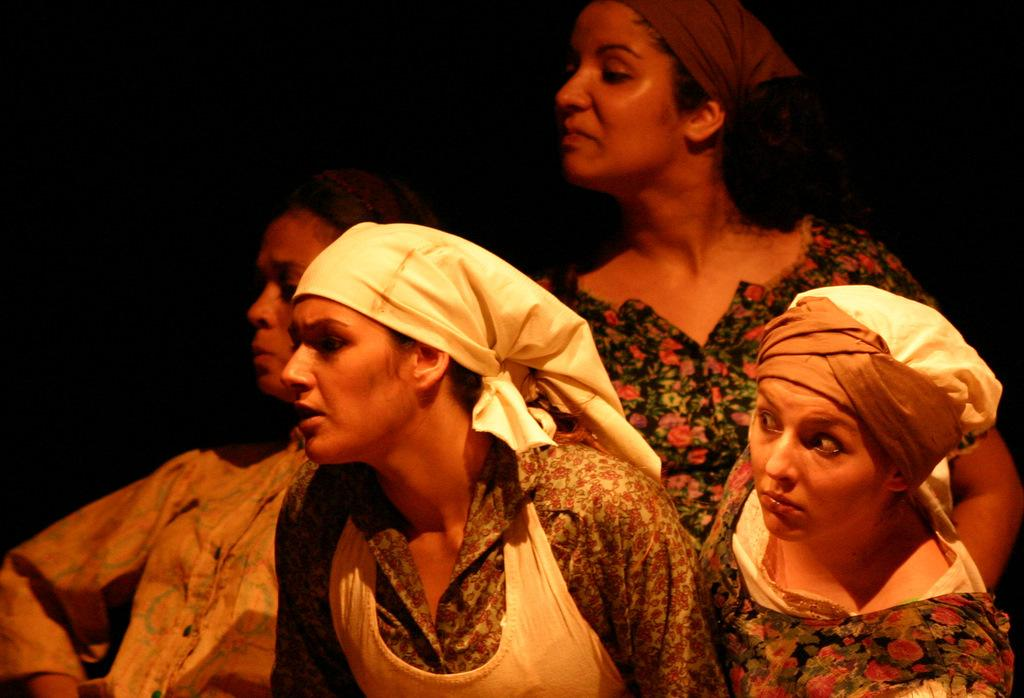What is the main subject of the image? The main subject of the image is a group of people. Where are the people located in the image? The group of people is at the bottom of the image. What can be observed about the background of the image? The background of the image is dark. What type of insurance policy is being discussed by the group of people in the image? There is no indication in the image that the group of people is discussing any insurance policies. 